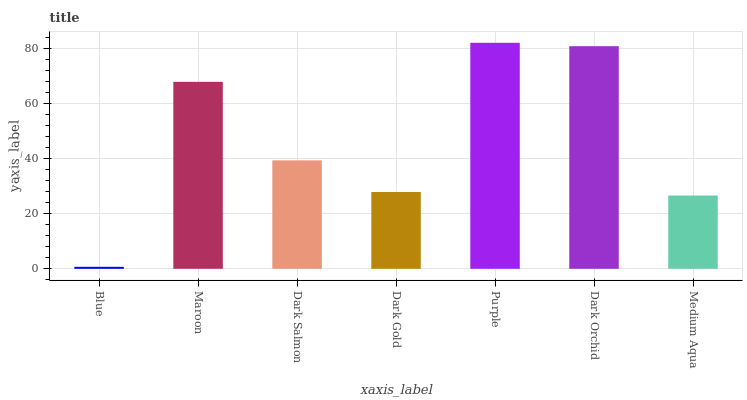Is Blue the minimum?
Answer yes or no. Yes. Is Purple the maximum?
Answer yes or no. Yes. Is Maroon the minimum?
Answer yes or no. No. Is Maroon the maximum?
Answer yes or no. No. Is Maroon greater than Blue?
Answer yes or no. Yes. Is Blue less than Maroon?
Answer yes or no. Yes. Is Blue greater than Maroon?
Answer yes or no. No. Is Maroon less than Blue?
Answer yes or no. No. Is Dark Salmon the high median?
Answer yes or no. Yes. Is Dark Salmon the low median?
Answer yes or no. Yes. Is Purple the high median?
Answer yes or no. No. Is Dark Gold the low median?
Answer yes or no. No. 